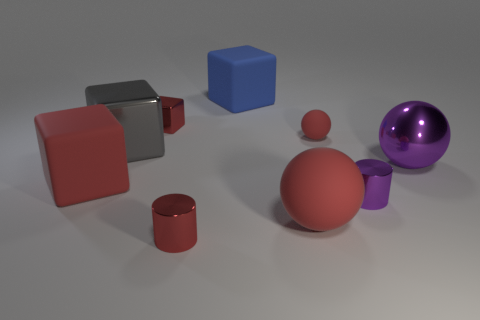Does the blue cube have the same size as the purple metallic cylinder? Based on the visual comparison, no, the blue cube does not have the same size as the purple metallic cylinder. The cube appears to be smaller in dimensions compared to the height and diameter of the cylinder. 